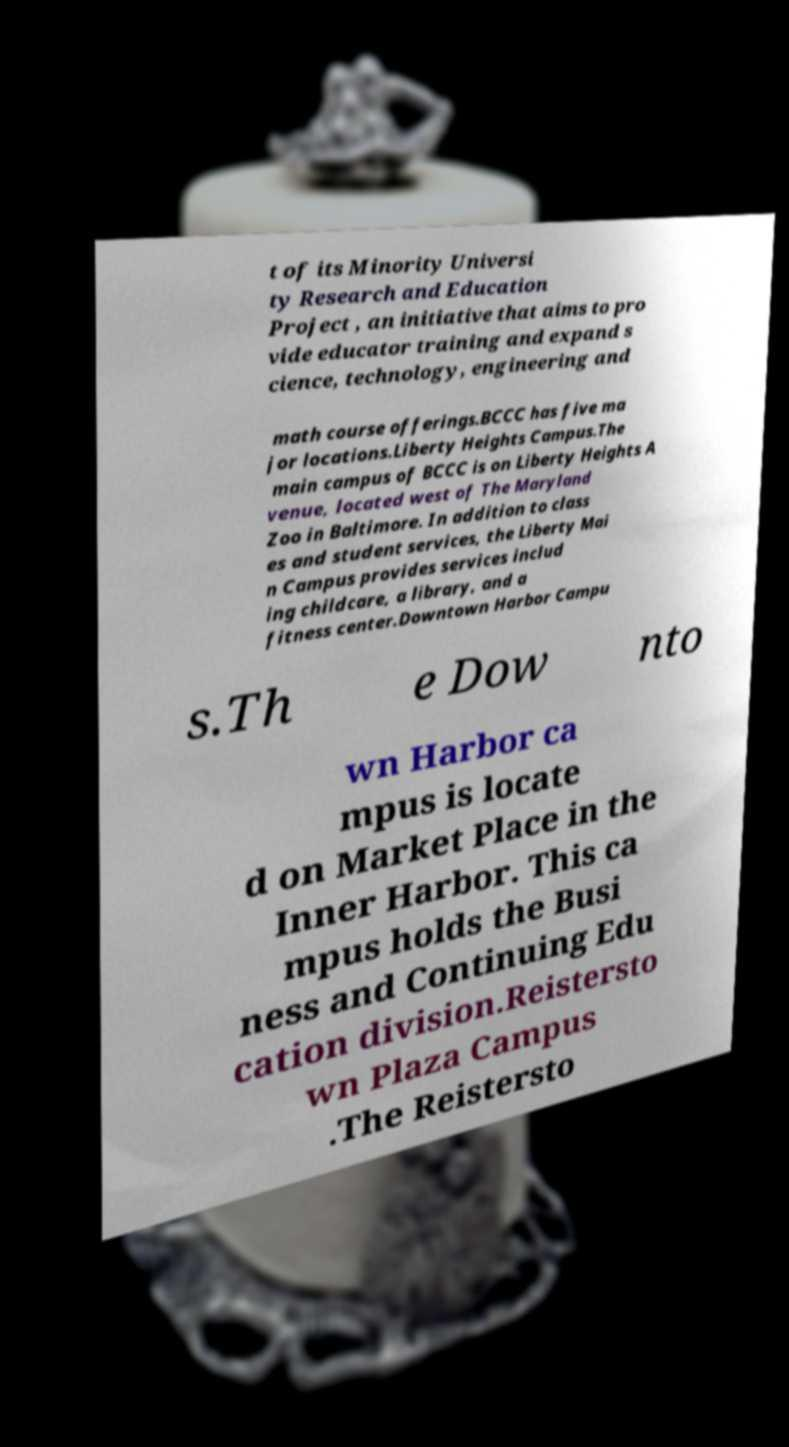I need the written content from this picture converted into text. Can you do that? t of its Minority Universi ty Research and Education Project , an initiative that aims to pro vide educator training and expand s cience, technology, engineering and math course offerings.BCCC has five ma jor locations.Liberty Heights Campus.The main campus of BCCC is on Liberty Heights A venue, located west of The Maryland Zoo in Baltimore. In addition to class es and student services, the Liberty Mai n Campus provides services includ ing childcare, a library, and a fitness center.Downtown Harbor Campu s.Th e Dow nto wn Harbor ca mpus is locate d on Market Place in the Inner Harbor. This ca mpus holds the Busi ness and Continuing Edu cation division.Reistersto wn Plaza Campus .The Reistersto 